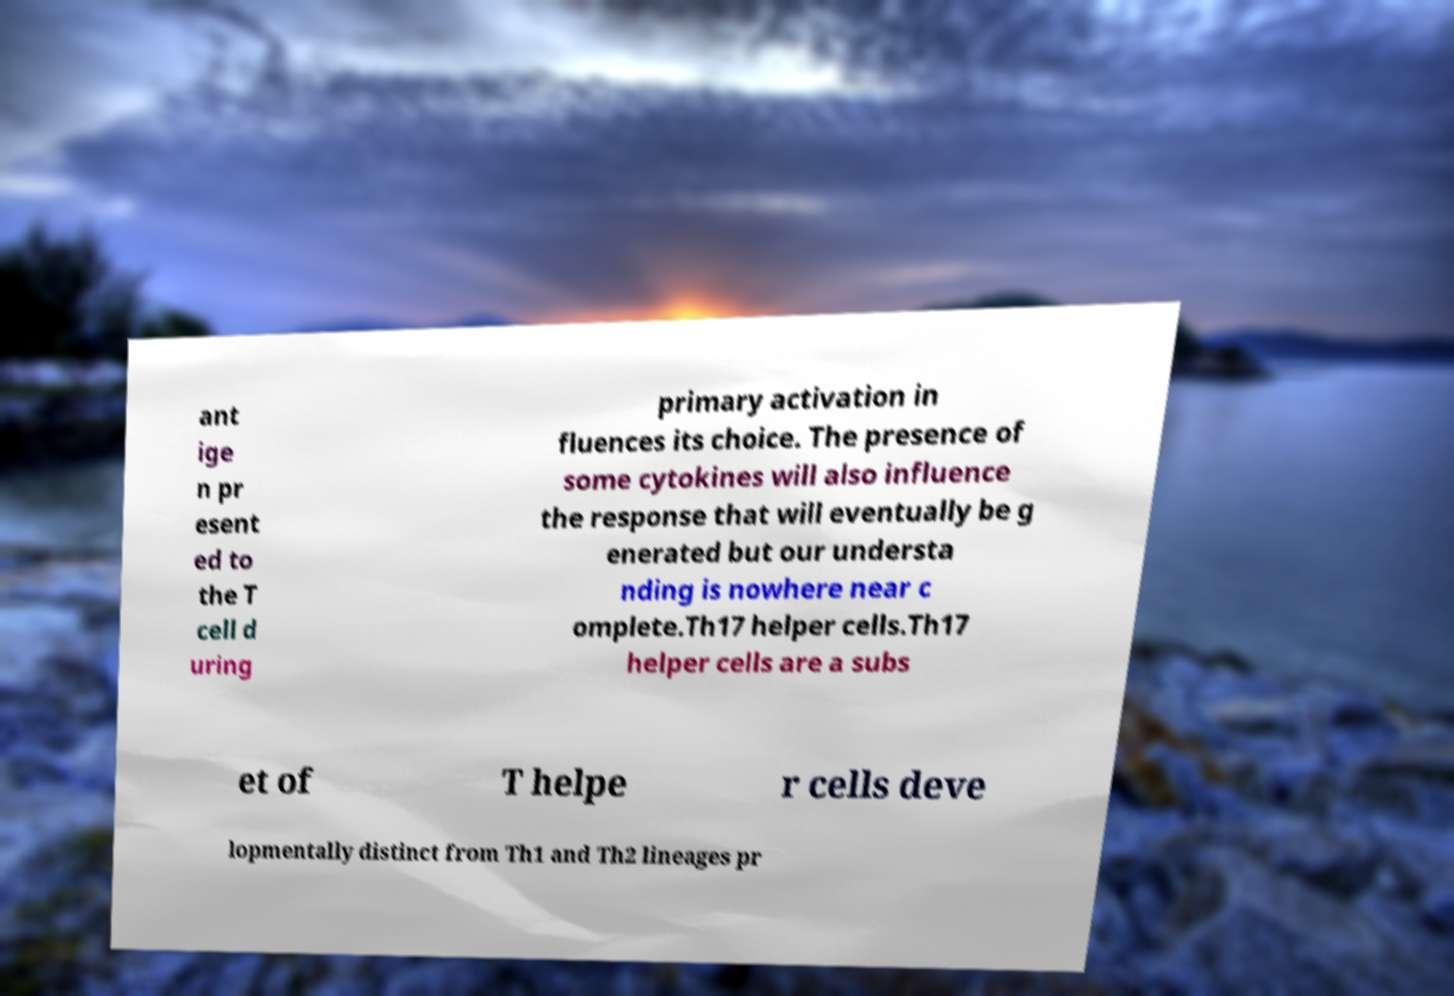Can you accurately transcribe the text from the provided image for me? ant ige n pr esent ed to the T cell d uring primary activation in fluences its choice. The presence of some cytokines will also influence the response that will eventually be g enerated but our understa nding is nowhere near c omplete.Th17 helper cells.Th17 helper cells are a subs et of T helpe r cells deve lopmentally distinct from Th1 and Th2 lineages pr 